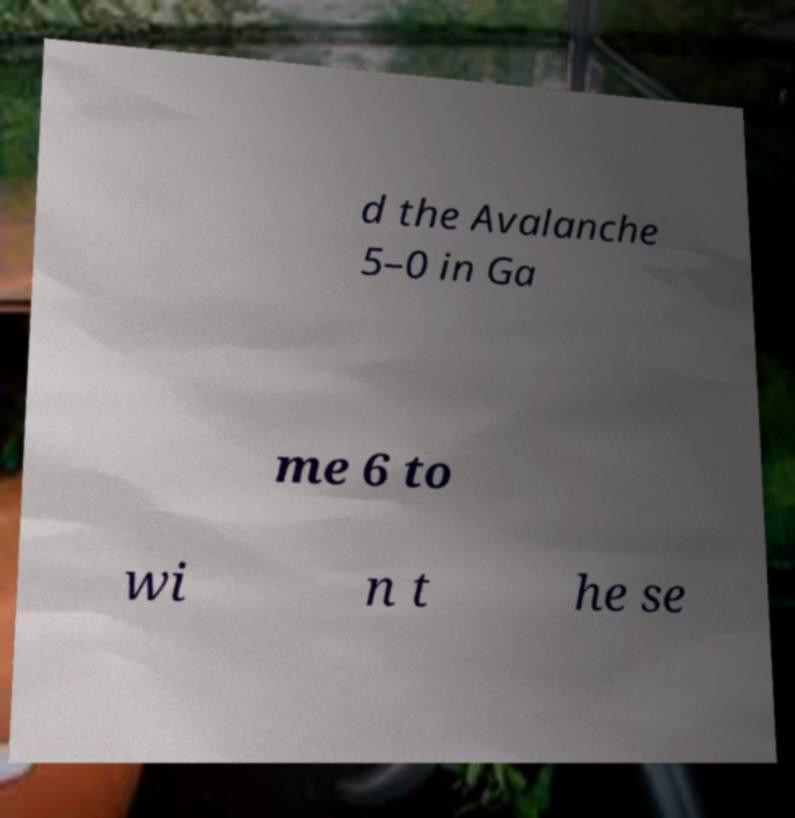Please read and relay the text visible in this image. What does it say? d the Avalanche 5–0 in Ga me 6 to wi n t he se 